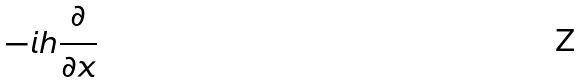<formula> <loc_0><loc_0><loc_500><loc_500>- i h \frac { \partial } { \partial x }</formula> 